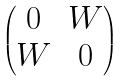<formula> <loc_0><loc_0><loc_500><loc_500>\begin{pmatrix} 0 & W \\ W & 0 \end{pmatrix}</formula> 